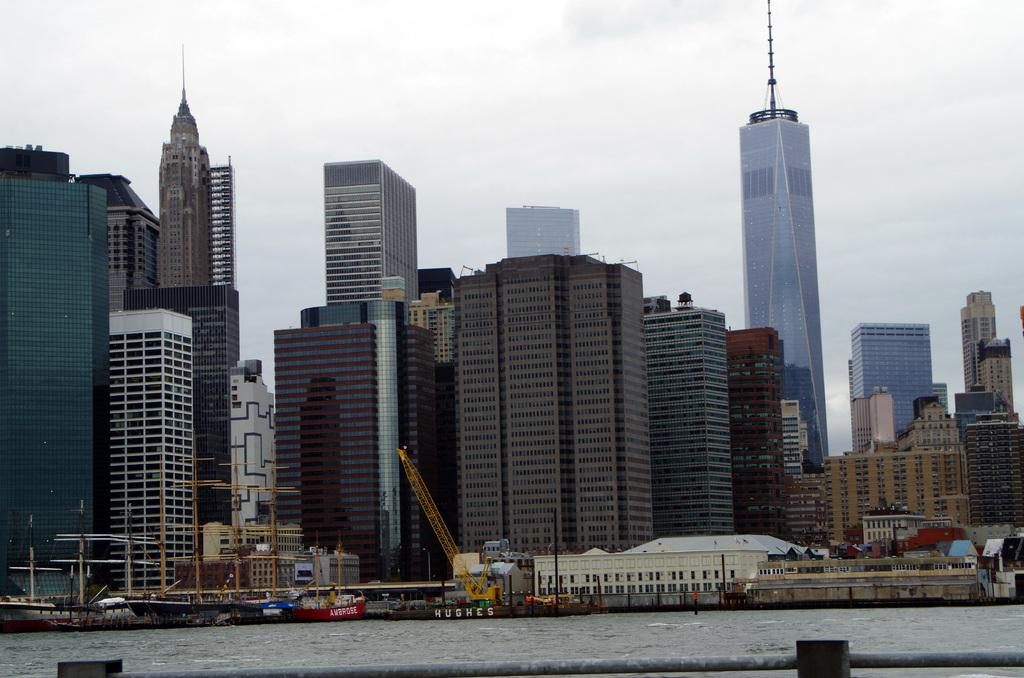What is the main subject of the image? There is a crane in the image. What can be seen in the water in the image? There are ships in the water in the image. What object is visible in the foreground of the image? There is a rod visible in the image. What type of structures can be seen in the background of the image? There are buildings visible in the background of the image. How would you describe the weather in the image? The sky is cloudy in the image. What type of cherry is being used as a bat in the image? There is no cherry or bat present in the image; it features a crane, ships, a rod, buildings, and a cloudy sky. 